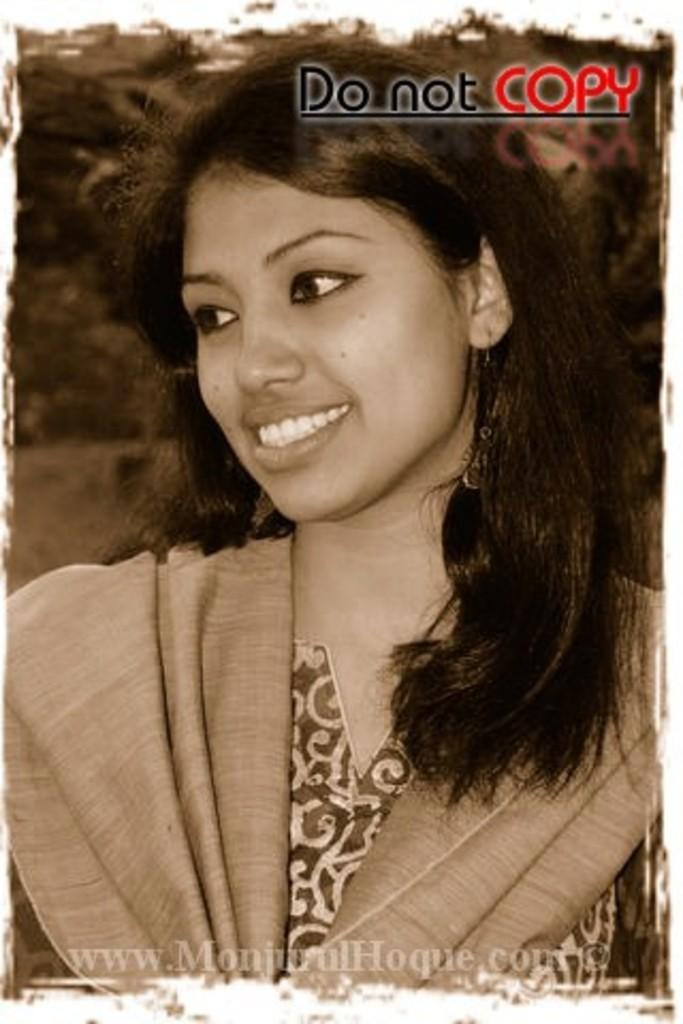What is depicted in the image? There is a picture of a lady person in the image. What expression does the lady person have? The lady person is smiling. How many eyes does the lady person have in the image? The number of eyes cannot be determined from the image, as it is a two-dimensional representation of the lady person. 